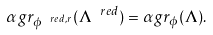<formula> <loc_0><loc_0><loc_500><loc_500>\alpha g r _ { \phi ^ { \ r e d , r } } ( \Lambda ^ { \ r e d } ) = \alpha g r _ { \phi } ( \Lambda ) .</formula> 